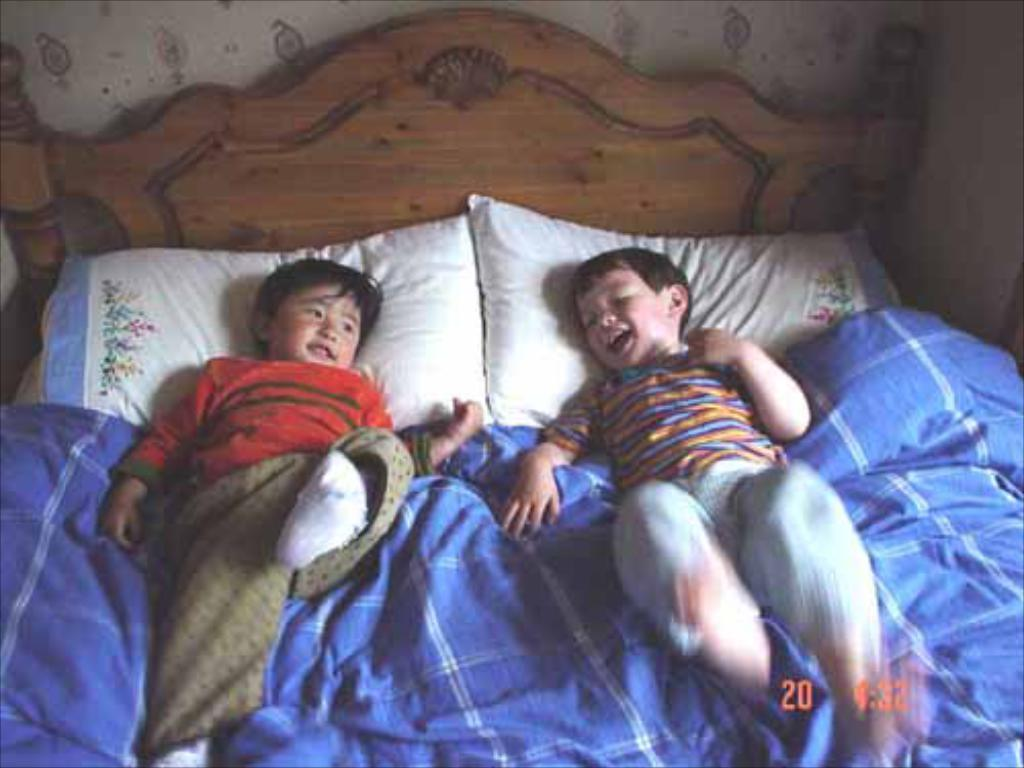How many children are present in the image? There are two kids in the image. What are the kids doing in the image? The kids are laying on a bed. What type of calculator is being used by the committee in the image? There is no calculator or committee present in the image; it features two kids laying on a bed. 